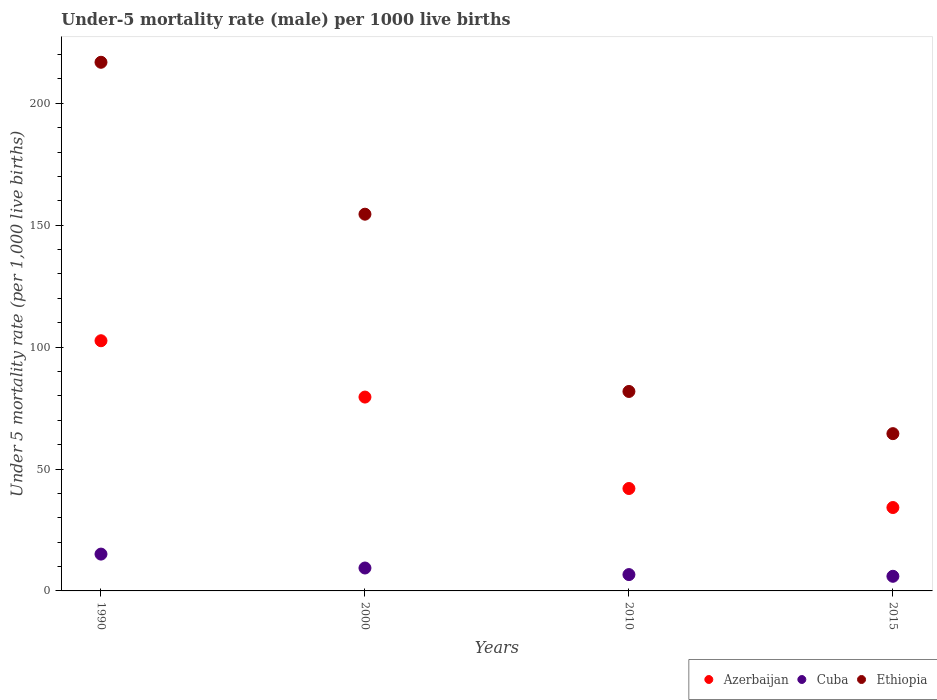What is the under-five mortality rate in Azerbaijan in 1990?
Your answer should be compact. 102.6. Across all years, what is the maximum under-five mortality rate in Azerbaijan?
Ensure brevity in your answer.  102.6. Across all years, what is the minimum under-five mortality rate in Azerbaijan?
Ensure brevity in your answer.  34.2. In which year was the under-five mortality rate in Ethiopia maximum?
Your answer should be very brief. 1990. In which year was the under-five mortality rate in Ethiopia minimum?
Offer a very short reply. 2015. What is the total under-five mortality rate in Ethiopia in the graph?
Provide a succinct answer. 517.6. What is the difference between the under-five mortality rate in Azerbaijan in 2000 and that in 2015?
Provide a succinct answer. 45.3. What is the difference between the under-five mortality rate in Ethiopia in 2000 and the under-five mortality rate in Azerbaijan in 1990?
Your response must be concise. 51.9. What is the average under-five mortality rate in Ethiopia per year?
Your answer should be very brief. 129.4. In the year 2010, what is the difference between the under-five mortality rate in Cuba and under-five mortality rate in Ethiopia?
Offer a very short reply. -75.1. What is the ratio of the under-five mortality rate in Azerbaijan in 2010 to that in 2015?
Offer a terse response. 1.23. Is the under-five mortality rate in Azerbaijan in 2010 less than that in 2015?
Offer a very short reply. No. What is the difference between the highest and the second highest under-five mortality rate in Ethiopia?
Your answer should be very brief. 62.3. What is the difference between the highest and the lowest under-five mortality rate in Ethiopia?
Offer a very short reply. 152.3. Is the sum of the under-five mortality rate in Cuba in 2000 and 2010 greater than the maximum under-five mortality rate in Azerbaijan across all years?
Provide a succinct answer. No. Is the under-five mortality rate in Cuba strictly less than the under-five mortality rate in Azerbaijan over the years?
Your response must be concise. Yes. How many dotlines are there?
Your answer should be very brief. 3. How many years are there in the graph?
Make the answer very short. 4. Does the graph contain grids?
Keep it short and to the point. No. Where does the legend appear in the graph?
Make the answer very short. Bottom right. How are the legend labels stacked?
Your response must be concise. Horizontal. What is the title of the graph?
Provide a succinct answer. Under-5 mortality rate (male) per 1000 live births. Does "Bosnia and Herzegovina" appear as one of the legend labels in the graph?
Ensure brevity in your answer.  No. What is the label or title of the X-axis?
Give a very brief answer. Years. What is the label or title of the Y-axis?
Give a very brief answer. Under 5 mortality rate (per 1,0 live births). What is the Under 5 mortality rate (per 1,000 live births) of Azerbaijan in 1990?
Offer a very short reply. 102.6. What is the Under 5 mortality rate (per 1,000 live births) in Cuba in 1990?
Provide a succinct answer. 15.1. What is the Under 5 mortality rate (per 1,000 live births) in Ethiopia in 1990?
Offer a very short reply. 216.8. What is the Under 5 mortality rate (per 1,000 live births) in Azerbaijan in 2000?
Your response must be concise. 79.5. What is the Under 5 mortality rate (per 1,000 live births) in Cuba in 2000?
Your answer should be compact. 9.4. What is the Under 5 mortality rate (per 1,000 live births) of Ethiopia in 2000?
Your answer should be very brief. 154.5. What is the Under 5 mortality rate (per 1,000 live births) of Azerbaijan in 2010?
Provide a succinct answer. 42. What is the Under 5 mortality rate (per 1,000 live births) in Ethiopia in 2010?
Offer a very short reply. 81.8. What is the Under 5 mortality rate (per 1,000 live births) of Azerbaijan in 2015?
Your answer should be compact. 34.2. What is the Under 5 mortality rate (per 1,000 live births) of Cuba in 2015?
Your answer should be very brief. 6. What is the Under 5 mortality rate (per 1,000 live births) of Ethiopia in 2015?
Make the answer very short. 64.5. Across all years, what is the maximum Under 5 mortality rate (per 1,000 live births) of Azerbaijan?
Make the answer very short. 102.6. Across all years, what is the maximum Under 5 mortality rate (per 1,000 live births) of Cuba?
Offer a very short reply. 15.1. Across all years, what is the maximum Under 5 mortality rate (per 1,000 live births) of Ethiopia?
Offer a terse response. 216.8. Across all years, what is the minimum Under 5 mortality rate (per 1,000 live births) in Azerbaijan?
Ensure brevity in your answer.  34.2. Across all years, what is the minimum Under 5 mortality rate (per 1,000 live births) of Ethiopia?
Keep it short and to the point. 64.5. What is the total Under 5 mortality rate (per 1,000 live births) in Azerbaijan in the graph?
Your answer should be compact. 258.3. What is the total Under 5 mortality rate (per 1,000 live births) of Cuba in the graph?
Make the answer very short. 37.2. What is the total Under 5 mortality rate (per 1,000 live births) of Ethiopia in the graph?
Provide a succinct answer. 517.6. What is the difference between the Under 5 mortality rate (per 1,000 live births) in Azerbaijan in 1990 and that in 2000?
Provide a short and direct response. 23.1. What is the difference between the Under 5 mortality rate (per 1,000 live births) in Cuba in 1990 and that in 2000?
Ensure brevity in your answer.  5.7. What is the difference between the Under 5 mortality rate (per 1,000 live births) in Ethiopia in 1990 and that in 2000?
Keep it short and to the point. 62.3. What is the difference between the Under 5 mortality rate (per 1,000 live births) of Azerbaijan in 1990 and that in 2010?
Give a very brief answer. 60.6. What is the difference between the Under 5 mortality rate (per 1,000 live births) in Cuba in 1990 and that in 2010?
Offer a very short reply. 8.4. What is the difference between the Under 5 mortality rate (per 1,000 live births) of Ethiopia in 1990 and that in 2010?
Provide a short and direct response. 135. What is the difference between the Under 5 mortality rate (per 1,000 live births) of Azerbaijan in 1990 and that in 2015?
Make the answer very short. 68.4. What is the difference between the Under 5 mortality rate (per 1,000 live births) in Cuba in 1990 and that in 2015?
Provide a short and direct response. 9.1. What is the difference between the Under 5 mortality rate (per 1,000 live births) of Ethiopia in 1990 and that in 2015?
Keep it short and to the point. 152.3. What is the difference between the Under 5 mortality rate (per 1,000 live births) in Azerbaijan in 2000 and that in 2010?
Keep it short and to the point. 37.5. What is the difference between the Under 5 mortality rate (per 1,000 live births) in Ethiopia in 2000 and that in 2010?
Your response must be concise. 72.7. What is the difference between the Under 5 mortality rate (per 1,000 live births) in Azerbaijan in 2000 and that in 2015?
Ensure brevity in your answer.  45.3. What is the difference between the Under 5 mortality rate (per 1,000 live births) in Cuba in 2000 and that in 2015?
Give a very brief answer. 3.4. What is the difference between the Under 5 mortality rate (per 1,000 live births) of Ethiopia in 2000 and that in 2015?
Provide a short and direct response. 90. What is the difference between the Under 5 mortality rate (per 1,000 live births) of Azerbaijan in 1990 and the Under 5 mortality rate (per 1,000 live births) of Cuba in 2000?
Make the answer very short. 93.2. What is the difference between the Under 5 mortality rate (per 1,000 live births) in Azerbaijan in 1990 and the Under 5 mortality rate (per 1,000 live births) in Ethiopia in 2000?
Provide a short and direct response. -51.9. What is the difference between the Under 5 mortality rate (per 1,000 live births) of Cuba in 1990 and the Under 5 mortality rate (per 1,000 live births) of Ethiopia in 2000?
Make the answer very short. -139.4. What is the difference between the Under 5 mortality rate (per 1,000 live births) of Azerbaijan in 1990 and the Under 5 mortality rate (per 1,000 live births) of Cuba in 2010?
Your answer should be compact. 95.9. What is the difference between the Under 5 mortality rate (per 1,000 live births) of Azerbaijan in 1990 and the Under 5 mortality rate (per 1,000 live births) of Ethiopia in 2010?
Ensure brevity in your answer.  20.8. What is the difference between the Under 5 mortality rate (per 1,000 live births) in Cuba in 1990 and the Under 5 mortality rate (per 1,000 live births) in Ethiopia in 2010?
Your answer should be very brief. -66.7. What is the difference between the Under 5 mortality rate (per 1,000 live births) in Azerbaijan in 1990 and the Under 5 mortality rate (per 1,000 live births) in Cuba in 2015?
Provide a short and direct response. 96.6. What is the difference between the Under 5 mortality rate (per 1,000 live births) in Azerbaijan in 1990 and the Under 5 mortality rate (per 1,000 live births) in Ethiopia in 2015?
Your answer should be very brief. 38.1. What is the difference between the Under 5 mortality rate (per 1,000 live births) of Cuba in 1990 and the Under 5 mortality rate (per 1,000 live births) of Ethiopia in 2015?
Provide a succinct answer. -49.4. What is the difference between the Under 5 mortality rate (per 1,000 live births) in Azerbaijan in 2000 and the Under 5 mortality rate (per 1,000 live births) in Cuba in 2010?
Offer a terse response. 72.8. What is the difference between the Under 5 mortality rate (per 1,000 live births) in Azerbaijan in 2000 and the Under 5 mortality rate (per 1,000 live births) in Ethiopia in 2010?
Keep it short and to the point. -2.3. What is the difference between the Under 5 mortality rate (per 1,000 live births) in Cuba in 2000 and the Under 5 mortality rate (per 1,000 live births) in Ethiopia in 2010?
Ensure brevity in your answer.  -72.4. What is the difference between the Under 5 mortality rate (per 1,000 live births) in Azerbaijan in 2000 and the Under 5 mortality rate (per 1,000 live births) in Cuba in 2015?
Make the answer very short. 73.5. What is the difference between the Under 5 mortality rate (per 1,000 live births) in Cuba in 2000 and the Under 5 mortality rate (per 1,000 live births) in Ethiopia in 2015?
Your answer should be compact. -55.1. What is the difference between the Under 5 mortality rate (per 1,000 live births) of Azerbaijan in 2010 and the Under 5 mortality rate (per 1,000 live births) of Ethiopia in 2015?
Offer a very short reply. -22.5. What is the difference between the Under 5 mortality rate (per 1,000 live births) in Cuba in 2010 and the Under 5 mortality rate (per 1,000 live births) in Ethiopia in 2015?
Provide a short and direct response. -57.8. What is the average Under 5 mortality rate (per 1,000 live births) of Azerbaijan per year?
Offer a terse response. 64.58. What is the average Under 5 mortality rate (per 1,000 live births) in Ethiopia per year?
Provide a succinct answer. 129.4. In the year 1990, what is the difference between the Under 5 mortality rate (per 1,000 live births) in Azerbaijan and Under 5 mortality rate (per 1,000 live births) in Cuba?
Ensure brevity in your answer.  87.5. In the year 1990, what is the difference between the Under 5 mortality rate (per 1,000 live births) in Azerbaijan and Under 5 mortality rate (per 1,000 live births) in Ethiopia?
Your answer should be very brief. -114.2. In the year 1990, what is the difference between the Under 5 mortality rate (per 1,000 live births) in Cuba and Under 5 mortality rate (per 1,000 live births) in Ethiopia?
Offer a terse response. -201.7. In the year 2000, what is the difference between the Under 5 mortality rate (per 1,000 live births) of Azerbaijan and Under 5 mortality rate (per 1,000 live births) of Cuba?
Your response must be concise. 70.1. In the year 2000, what is the difference between the Under 5 mortality rate (per 1,000 live births) of Azerbaijan and Under 5 mortality rate (per 1,000 live births) of Ethiopia?
Your answer should be very brief. -75. In the year 2000, what is the difference between the Under 5 mortality rate (per 1,000 live births) in Cuba and Under 5 mortality rate (per 1,000 live births) in Ethiopia?
Provide a short and direct response. -145.1. In the year 2010, what is the difference between the Under 5 mortality rate (per 1,000 live births) in Azerbaijan and Under 5 mortality rate (per 1,000 live births) in Cuba?
Offer a very short reply. 35.3. In the year 2010, what is the difference between the Under 5 mortality rate (per 1,000 live births) of Azerbaijan and Under 5 mortality rate (per 1,000 live births) of Ethiopia?
Provide a short and direct response. -39.8. In the year 2010, what is the difference between the Under 5 mortality rate (per 1,000 live births) in Cuba and Under 5 mortality rate (per 1,000 live births) in Ethiopia?
Provide a short and direct response. -75.1. In the year 2015, what is the difference between the Under 5 mortality rate (per 1,000 live births) of Azerbaijan and Under 5 mortality rate (per 1,000 live births) of Cuba?
Offer a terse response. 28.2. In the year 2015, what is the difference between the Under 5 mortality rate (per 1,000 live births) of Azerbaijan and Under 5 mortality rate (per 1,000 live births) of Ethiopia?
Make the answer very short. -30.3. In the year 2015, what is the difference between the Under 5 mortality rate (per 1,000 live births) of Cuba and Under 5 mortality rate (per 1,000 live births) of Ethiopia?
Your answer should be very brief. -58.5. What is the ratio of the Under 5 mortality rate (per 1,000 live births) of Azerbaijan in 1990 to that in 2000?
Offer a terse response. 1.29. What is the ratio of the Under 5 mortality rate (per 1,000 live births) in Cuba in 1990 to that in 2000?
Your answer should be very brief. 1.61. What is the ratio of the Under 5 mortality rate (per 1,000 live births) in Ethiopia in 1990 to that in 2000?
Offer a very short reply. 1.4. What is the ratio of the Under 5 mortality rate (per 1,000 live births) of Azerbaijan in 1990 to that in 2010?
Offer a very short reply. 2.44. What is the ratio of the Under 5 mortality rate (per 1,000 live births) of Cuba in 1990 to that in 2010?
Give a very brief answer. 2.25. What is the ratio of the Under 5 mortality rate (per 1,000 live births) of Ethiopia in 1990 to that in 2010?
Your response must be concise. 2.65. What is the ratio of the Under 5 mortality rate (per 1,000 live births) in Cuba in 1990 to that in 2015?
Ensure brevity in your answer.  2.52. What is the ratio of the Under 5 mortality rate (per 1,000 live births) in Ethiopia in 1990 to that in 2015?
Keep it short and to the point. 3.36. What is the ratio of the Under 5 mortality rate (per 1,000 live births) of Azerbaijan in 2000 to that in 2010?
Provide a succinct answer. 1.89. What is the ratio of the Under 5 mortality rate (per 1,000 live births) of Cuba in 2000 to that in 2010?
Keep it short and to the point. 1.4. What is the ratio of the Under 5 mortality rate (per 1,000 live births) of Ethiopia in 2000 to that in 2010?
Keep it short and to the point. 1.89. What is the ratio of the Under 5 mortality rate (per 1,000 live births) in Azerbaijan in 2000 to that in 2015?
Provide a short and direct response. 2.32. What is the ratio of the Under 5 mortality rate (per 1,000 live births) of Cuba in 2000 to that in 2015?
Make the answer very short. 1.57. What is the ratio of the Under 5 mortality rate (per 1,000 live births) in Ethiopia in 2000 to that in 2015?
Your answer should be compact. 2.4. What is the ratio of the Under 5 mortality rate (per 1,000 live births) of Azerbaijan in 2010 to that in 2015?
Ensure brevity in your answer.  1.23. What is the ratio of the Under 5 mortality rate (per 1,000 live births) of Cuba in 2010 to that in 2015?
Your answer should be very brief. 1.12. What is the ratio of the Under 5 mortality rate (per 1,000 live births) of Ethiopia in 2010 to that in 2015?
Make the answer very short. 1.27. What is the difference between the highest and the second highest Under 5 mortality rate (per 1,000 live births) of Azerbaijan?
Give a very brief answer. 23.1. What is the difference between the highest and the second highest Under 5 mortality rate (per 1,000 live births) in Ethiopia?
Provide a succinct answer. 62.3. What is the difference between the highest and the lowest Under 5 mortality rate (per 1,000 live births) in Azerbaijan?
Your answer should be compact. 68.4. What is the difference between the highest and the lowest Under 5 mortality rate (per 1,000 live births) in Ethiopia?
Your answer should be compact. 152.3. 